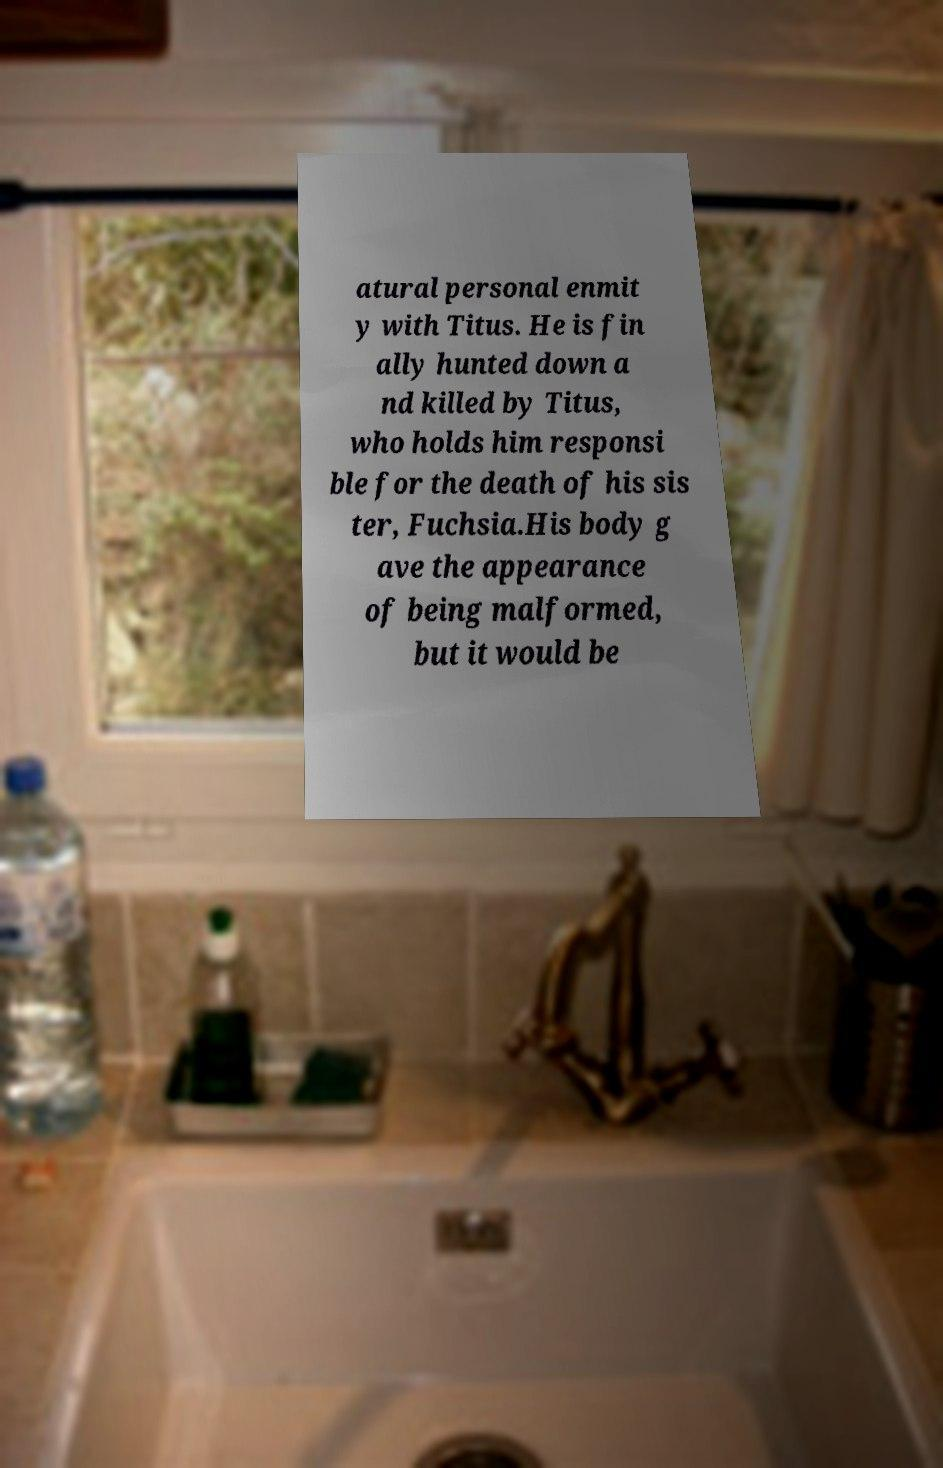Can you accurately transcribe the text from the provided image for me? atural personal enmit y with Titus. He is fin ally hunted down a nd killed by Titus, who holds him responsi ble for the death of his sis ter, Fuchsia.His body g ave the appearance of being malformed, but it would be 